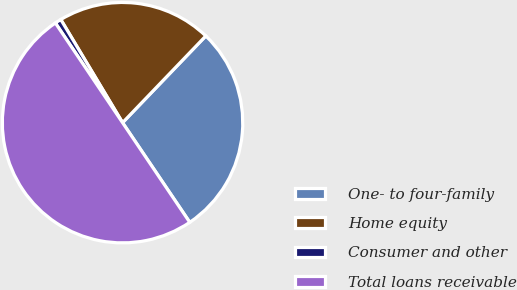Convert chart. <chart><loc_0><loc_0><loc_500><loc_500><pie_chart><fcel>One- to four-family<fcel>Home equity<fcel>Consumer and other<fcel>Total loans receivable<nl><fcel>28.38%<fcel>20.76%<fcel>0.85%<fcel>50.0%<nl></chart> 